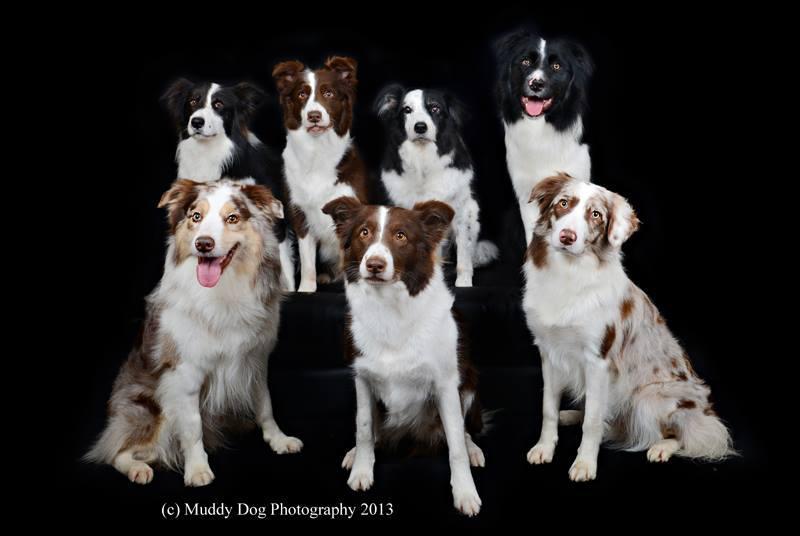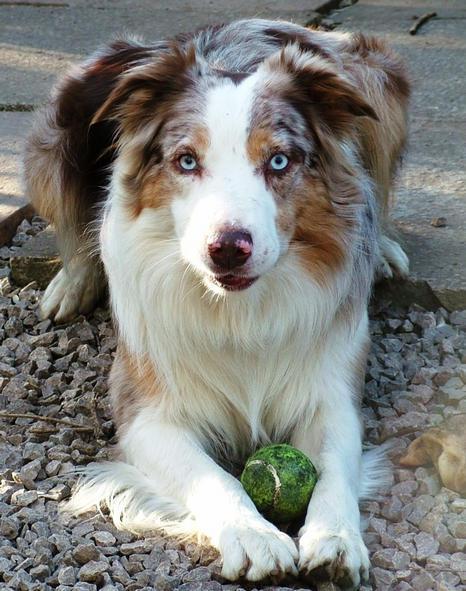The first image is the image on the left, the second image is the image on the right. Examine the images to the left and right. Is the description "There are three dogs in one picture and one dog in the other picture." accurate? Answer yes or no. No. The first image is the image on the left, the second image is the image on the right. Considering the images on both sides, is "The dog in the image on the right is laying down with their face pointing forward." valid? Answer yes or no. Yes. 